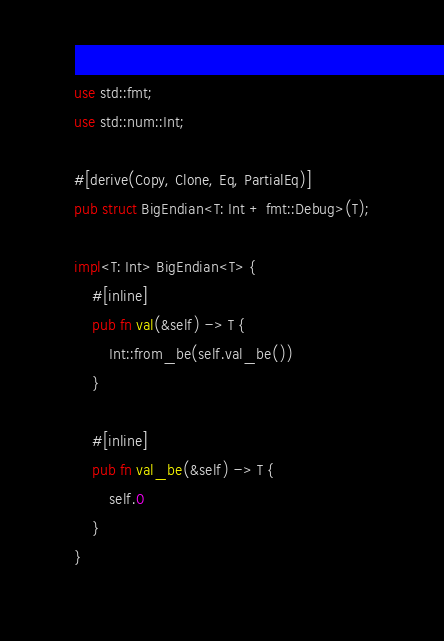<code> <loc_0><loc_0><loc_500><loc_500><_Rust_>use std::fmt;
use std::num::Int;

#[derive(Copy, Clone, Eq, PartialEq)]
pub struct BigEndian<T: Int + fmt::Debug>(T);

impl<T: Int> BigEndian<T> {
	#[inline]
	pub fn val(&self) -> T {
		Int::from_be(self.val_be())
	}

	#[inline]
	pub fn val_be(&self) -> T {
		self.0
	}
}
</code> 